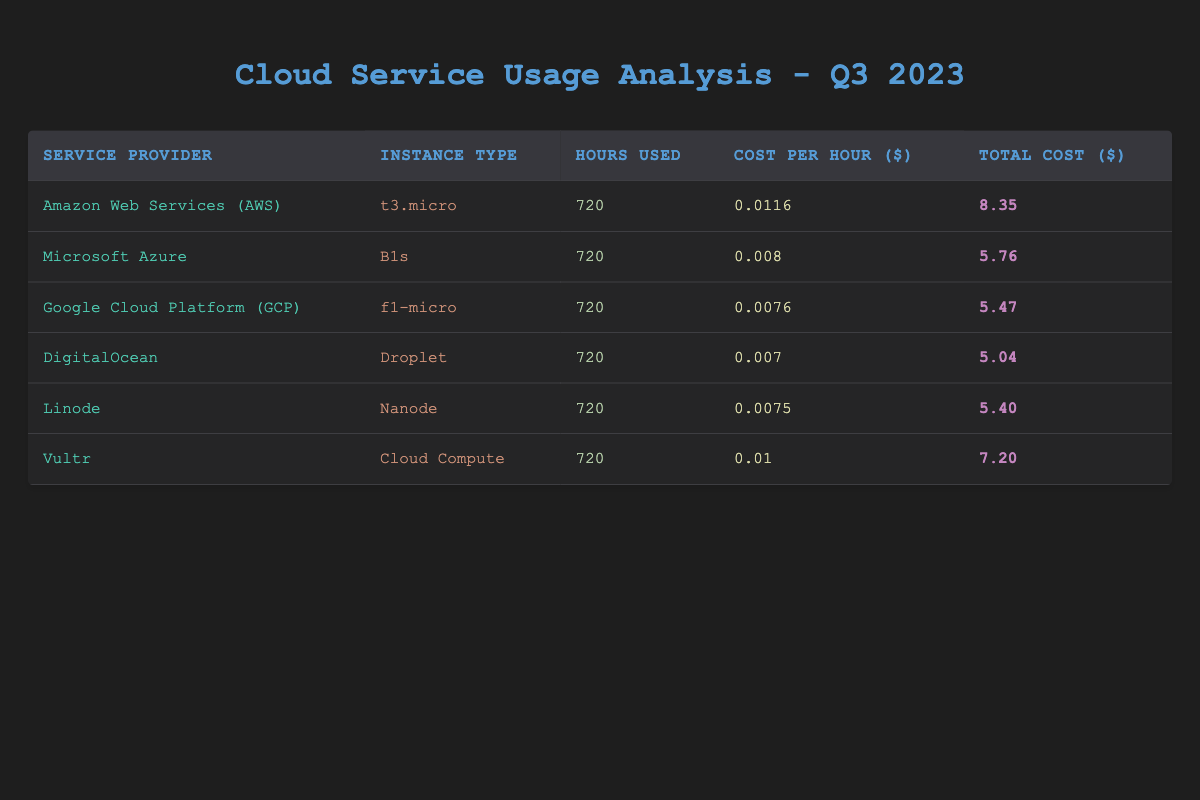What is the total cost of using Amazon Web Services (AWS) for the quarter? The total cost for AWS, as listed in the table, is directly stated as 8.35 dollars.
Answer: 8.35 Which service provider has the lowest cost per hour? By comparing the "Cost Per Hour" column, DigitalOcean has the lowest rate at 0.007 dollars per hour.
Answer: DigitalOcean What is the average total cost of all service providers listed? The total costs are: 8.35 + 5.76 + 5.47 + 5.04 + 5.40 + 7.20 = 37.22. There are 6 providers, so the average is 37.22 / 6 = 6.20.
Answer: 6.20 Is the total cost for Google Cloud Platform (GCP) less than 6 dollars? The total cost for GCP is 5.47 dollars, which is less than 6, confirming that this statement is true.
Answer: Yes How much more does AWS cost compared to DigitalOcean? AWS costs 8.35 dollars while DigitalOcean costs 5.04 dollars. The difference is calculated as 8.35 - 5.04 = 3.31 dollars.
Answer: 3.31 If you were to choose the service provider with the second-lowest total cost, which one would it be? The total costs are arranged as follows: DigitalOcean (5.04), GCP (5.47), Linode (5.40), Azure (5.76), Vultr (7.20), and AWS (8.35). The second-lowest total cost is from Linode with the total cost of 5.40 dollars.
Answer: Linode What is the total number of hours used across all service providers? Each provider used 720 hours, and there are 6 providers, so the total hours is calculated as 720 * 6 = 4320 hours.
Answer: 4320 Is it true that Microsoft Azure has a higher cost per hour than AWS? The cost per hour for Microsoft Azure is 0.008 dollars while AWS is 0.0116 dollars. Therefore, Azure's cost per hour is less than AWS, making this statement false.
Answer: No 